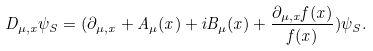Convert formula to latex. <formula><loc_0><loc_0><loc_500><loc_500>D _ { \mu , x } \psi _ { S } = ( \partial _ { \mu , x } + A _ { \mu } ( x ) + i B _ { \mu } ( x ) + \frac { \partial _ { \mu , x } f ( x ) } { f ( x ) } ) \psi _ { S } .</formula> 